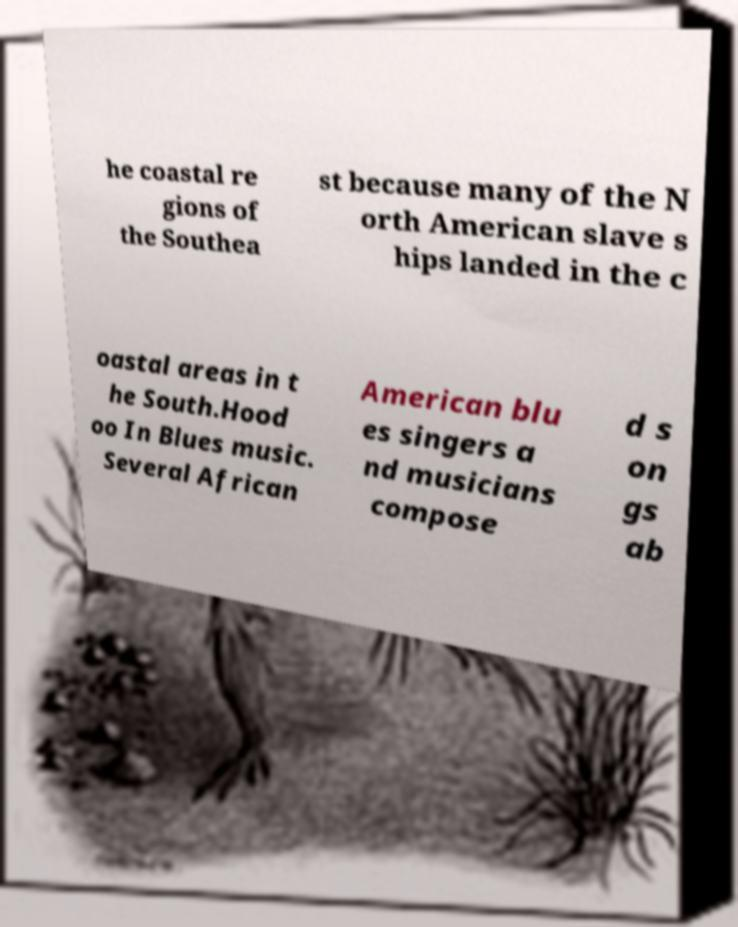Could you extract and type out the text from this image? he coastal re gions of the Southea st because many of the N orth American slave s hips landed in the c oastal areas in t he South.Hood oo In Blues music. Several African American blu es singers a nd musicians compose d s on gs ab 